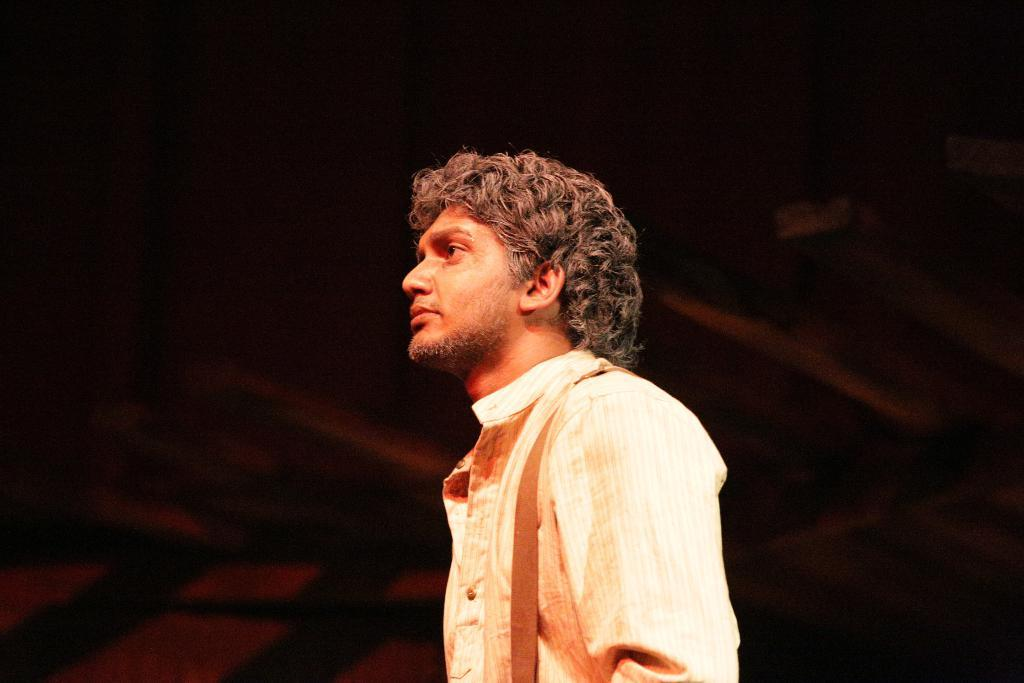Who is present in the image? There is a man in the image. What is the man wearing? The man is wearing a shirt. In which direction is the man looking? The man is looking to the left side. What is the color of the background in the image? The background of the image is black. What type of pail can be seen hanging from the man's belt in the image? There is no pail present in the image, and the man is not wearing a belt. 